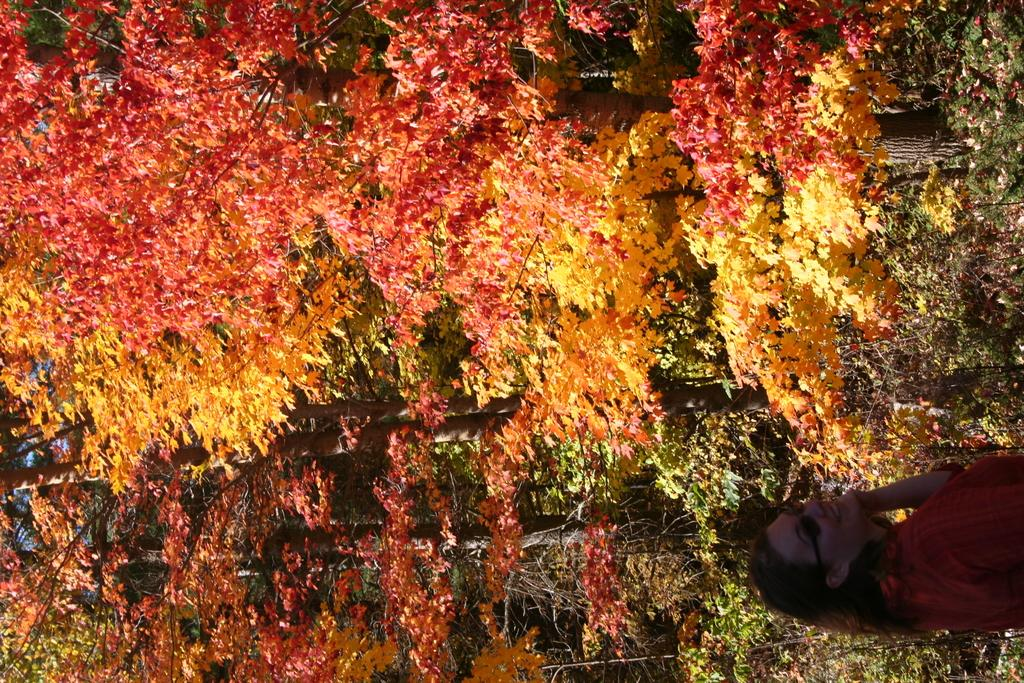What type of natural elements can be seen in the image? There are trees in the image. What is the primary subject of the image? There is a woman standing in the image. What accessory is the woman wearing? The woman is wearing spectacles. What type of language is being spoken by the apples in the image? There are no apples present in the image, and therefore no language being spoken by them. 